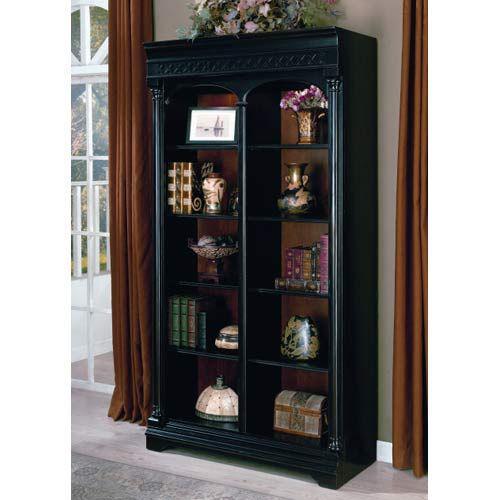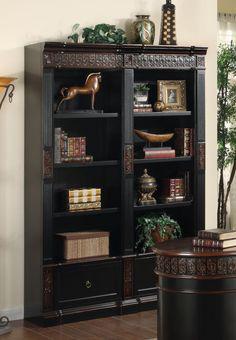The first image is the image on the left, the second image is the image on the right. Evaluate the accuracy of this statement regarding the images: "One large shelf unit is shown with an optional ladder accessory.". Is it true? Answer yes or no. No. 